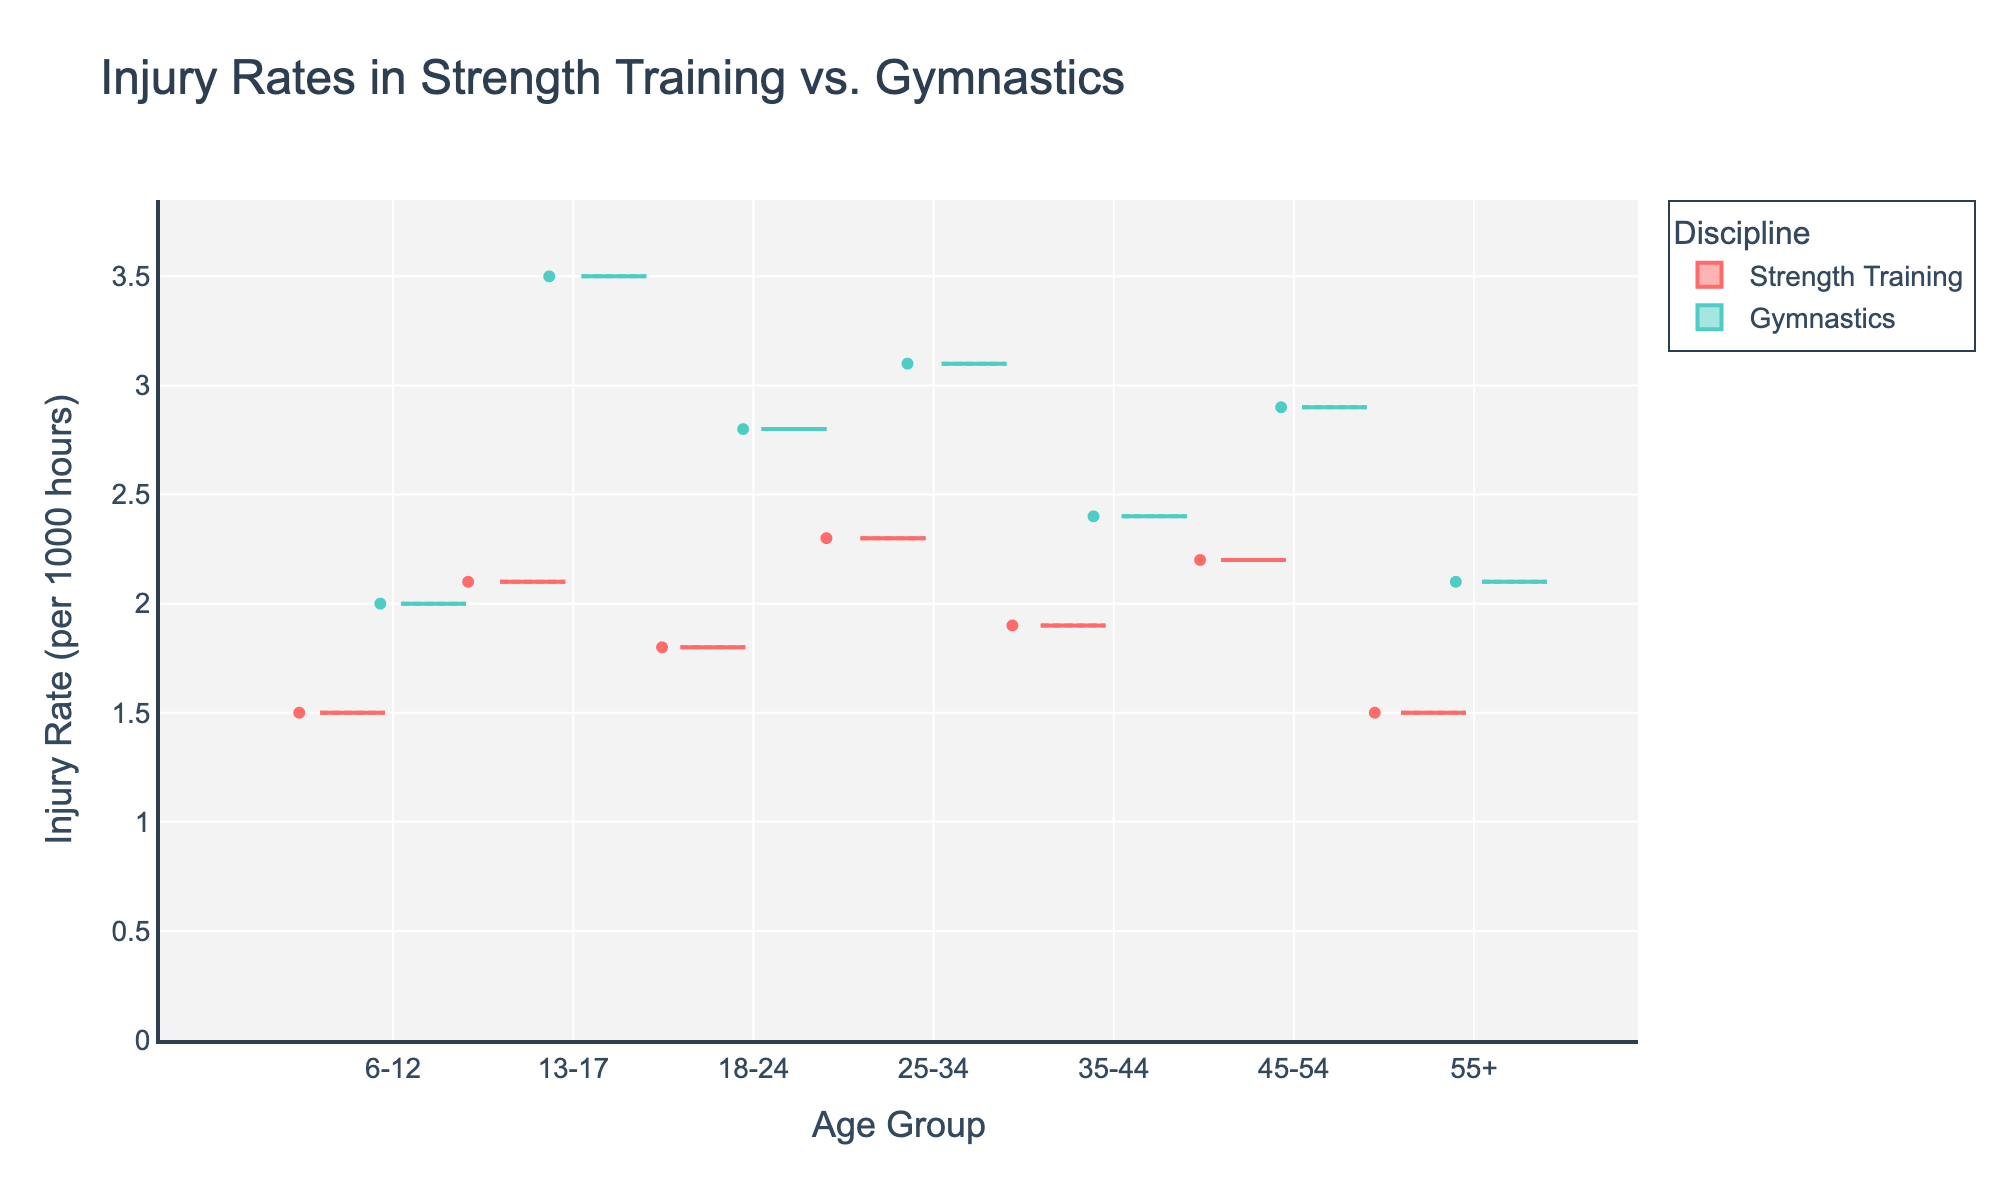How many age groups are shown in the figure? The figure displays data for different age groups. By counting the distinct age groups on the x-axis, we determine there are seven age groups: '6-12', '13-17', '18-24', '25-34', '35-44', '45-54', and '55+'.
Answer: Seven Which discipline has a higher injury rate for the '13-17' age group? To determine which discipline has a higher injury rate for the '13-17' age group, compare the boxes on the graph for Strength Training and Gymnastics. The injury rate for Gymnastics is higher than that for Strength Training.
Answer: Gymnastics What is the title of the figure? To find the title, look at the top of the figure where the title is typically displayed in a larger font size. The title in this case is 'Injury Rates in Strength Training vs. Gymnastics'.
Answer: Injury Rates in Strength Training vs. Gymnastics Which discipline shows more variability in injury rates across all age groups? To determine which discipline shows more variability, compare the spread (width) of the box plots for each discipline. Gymnastics has a wider spread compared to Strength Training, indicating more variability.
Answer: Gymnastics What is the median injury rate for Strength Training? To find the median injury rate for Strength Training, look at the middle line within each box plot for Strength Training across all age groups. The middle line represents the median for each group: 1.5, 2.1, 1.8, 2.3, 1.9, 2.2, and 1.5. To get the overall median, combine these values and find the middle value. Arranging them in ascending order gives: 1.5, 1.5, 1.8, 1.9, 2.1, 2.2, 2.3. The median is the fourth value.
Answer: 1.9 In which age group do Gymnastics and Strength Training show the smallest difference in injury rates? Calculate the difference in injury rates between Gymnastics and Strength Training for each age group by looking at the box plots. The smallest difference is in the '55+' age group where Gymnastics is 2.1 and Strength Training is 1.5, with a difference of 0.6.
Answer: 55+ Do older age groups (specifically 45+) have higher injury rates in Strength Training compared to the younger age groups (6-12)? To determine if older age groups have higher injury rates, compare the box plot injury rates for Strength Training at age 45+ to those at age 6-12. The rate for 45-54 is 2.2 and for 55+ it is 1.5, whereas for 6-12, it is 1.5. The injury rate for 45-54 is higher than for 6-12, but 55+ is the same.
Answer: No For which age group is the injury rate in Gymnastics the highest? To find the age group with the highest injury rate for Gymnastics, look at the box plot for Gymnastics and identify which age group has the highest median line. The '13-17' age group has the highest median injury rate at 3.5.
Answer: 13-17 Is the injury rate in Gymnastics consistently higher than in Strength Training across all age groups? To determine if Gymnastics has consistently higher injury rates, compare the heights of the box plots for each age group. In each age group (6-12, 13-17, 18-24, 25-34, 35-44, 45-54, 55+), the median injury rate for Gymnastics is higher than that for Strength Training.
Answer: Yes 